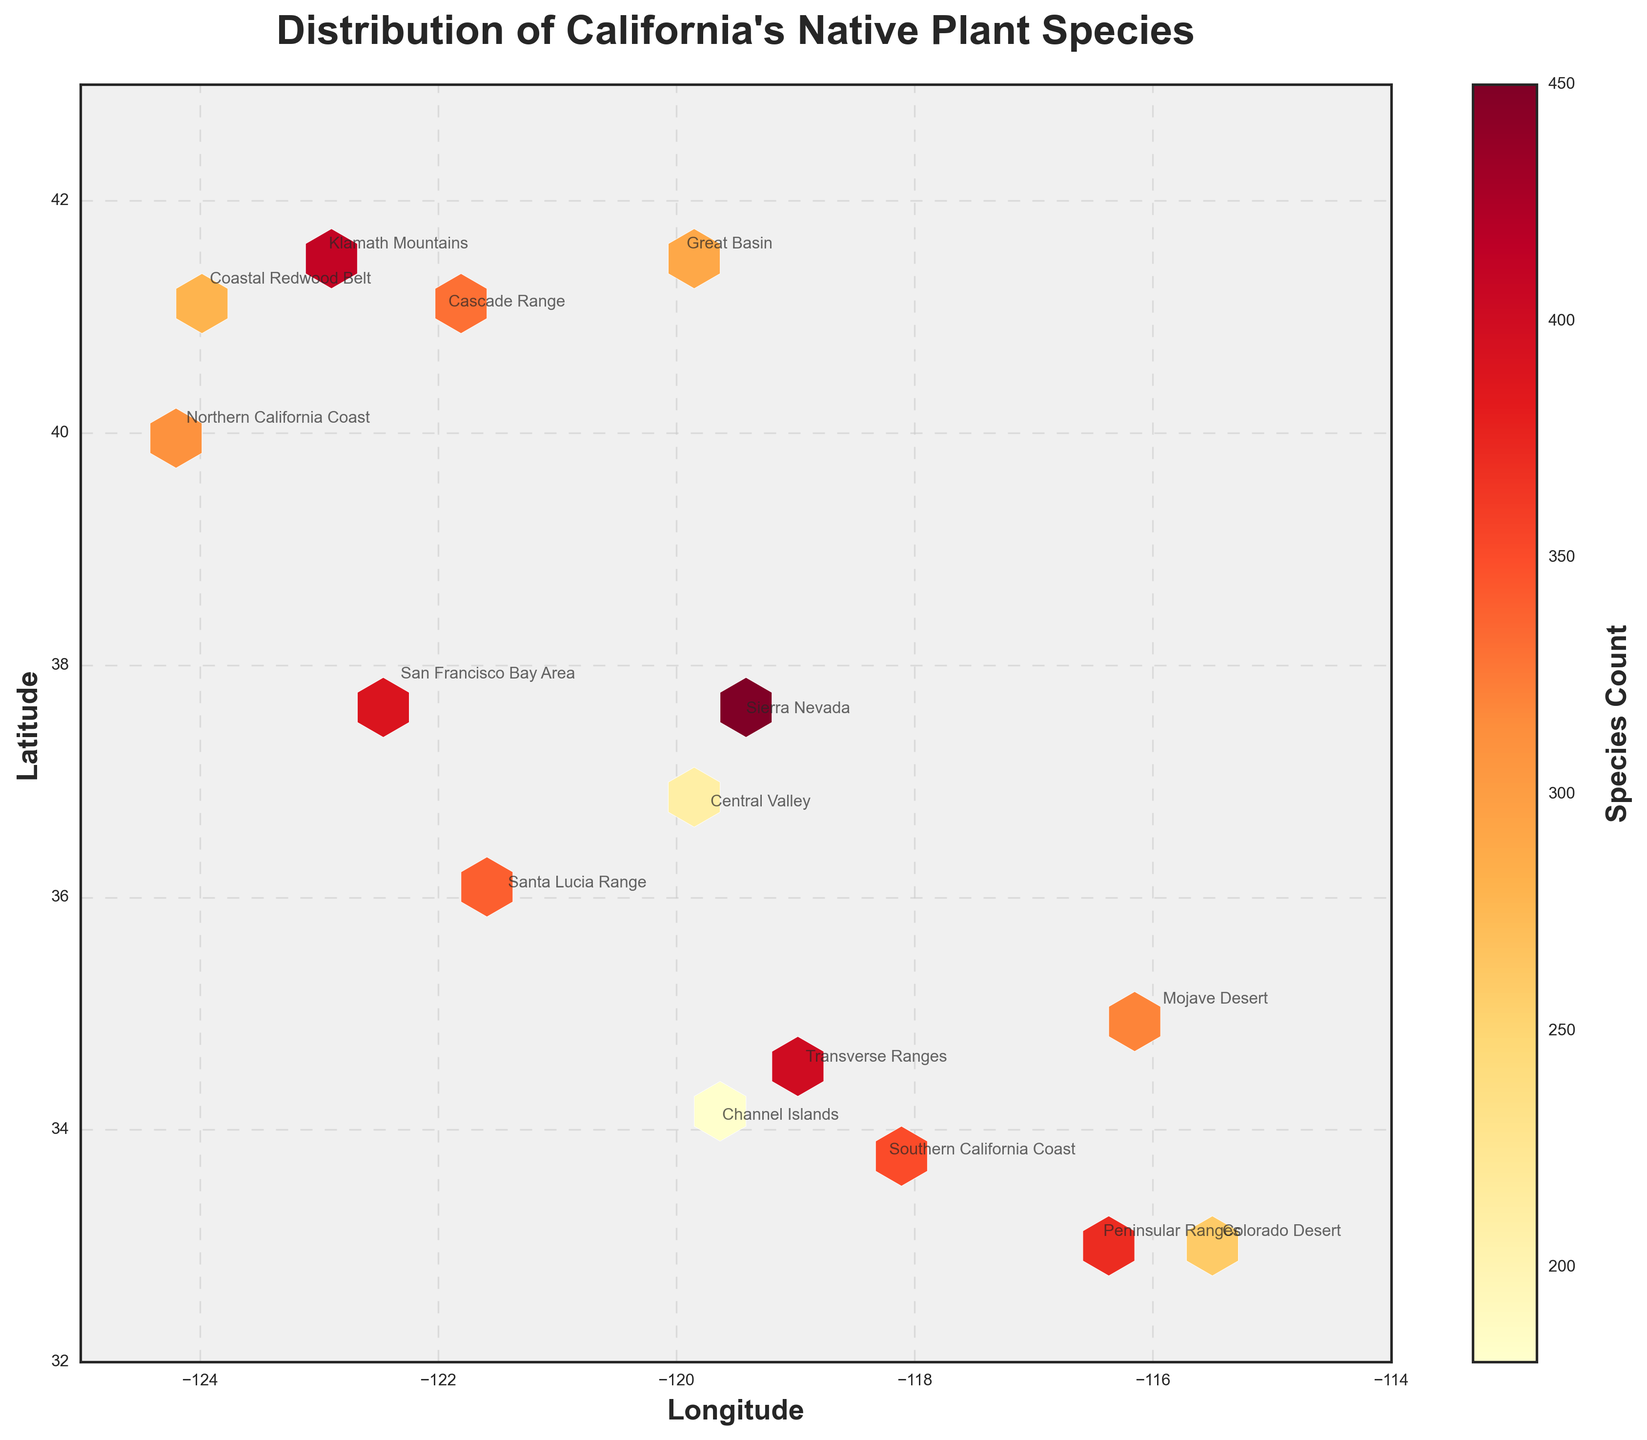Which region is located approximately at the longitude of -124.0 and latitude of 41.2? Look for the coordinate pair (longitude, latitude) that matches (-124.0, 41.2) and identify the annotated region in the figure.
Answer: Coastal Redwood Belt What is the title of the figure? The title is typically displayed prominently at the top of the figure.
Answer: Distribution of California's Native Plant Species Which region has the highest count of native plant species? Compare the number of species at each annotated region by referring to the values from the color intensity in the figure or region labels directly.
Answer: Sierra Nevada How many regions have a species count greater than 350? Count the number of regions with species counts higher than 350 based on the annotated labels or color intensity.
Answer: 5 What is the average species count for the Sierra Nevada, Klamath Mountains, and Transverse Ranges regions? Add the species counts for the three regions and divide by the number of regions: (450 + 410 + 400) / 3.
Answer: 420 Which has more species, the San Francisco Bay Area or the Central Valley? Compare the species counts of the San Francisco Bay Area and Central Valley from the annotated regions.
Answer: San Francisco Bay Area Is the species count of the Great Basin region higher or lower than the Southern California Coast region? Compare the species counts of the Great Basin and Southern California Coast regions based on the annotations.
Answer: Lower Which regions are located north of latitude 40? Identify the regions with latitudes higher than 40 based on their coordinates.
Answer: Coastal Redwood Belt, Klamath Mountains, Cascade Range, Great Basin Considering regions with latitudes lower than 34, which one has the highest species count? Among regions with latitudes less than 34, compare the species counts and find the highest one.
Answer: Peninsular Ranges 